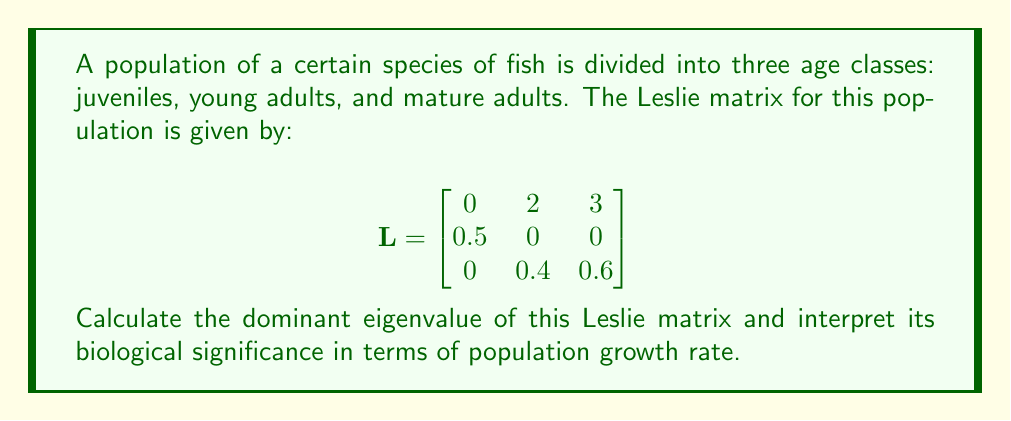What is the answer to this math problem? To solve this problem, we'll follow these steps:

1) First, we need to find the characteristic equation of the Leslie matrix. The characteristic equation is given by $det(L - \lambda I) = 0$, where $\lambda$ represents the eigenvalues.

2) Expanding the determinant:

   $$det\begin{bmatrix}
   -\lambda & 2 & 3 \\
   0.5 & -\lambda & 0 \\
   0 & 0.4 & 0.6-\lambda
   \end{bmatrix} = 0$$

3) This gives us the characteristic equation:

   $$-\lambda(-\lambda)(0.6-\lambda) + 2(0.4)(0.5) + 3(0.5)(-\lambda) = 0$$

4) Simplifying:

   $$-\lambda^3 + 0.6\lambda^2 + 0.4 - 1.5\lambda = 0$$
   $$\lambda^3 - 0.6\lambda^2 + 1.5\lambda - 0.4 = 0$$

5) This cubic equation can be solved numerically. Using a calculator or computer algebra system, we find that the largest real root (dominant eigenvalue) is approximately 1.0955.

6) Biological interpretation: In a Leslie matrix model, the dominant eigenvalue represents the asymptotic growth rate of the population. Since this value is greater than 1, it indicates that the population is growing over time.

7) More precisely, the population will grow by a factor of approximately 1.0955 (or 9.55%) with each time step, assuming the conditions represented by the Leslie matrix remain constant.

This growth rate is particularly relevant for evolutionary biology and natural selection, as it represents the fitness of the population under current conditions. A higher growth rate indicates better adaptation to the environment.
Answer: $\lambda \approx 1.0955$; population growing by 9.55% per time step 